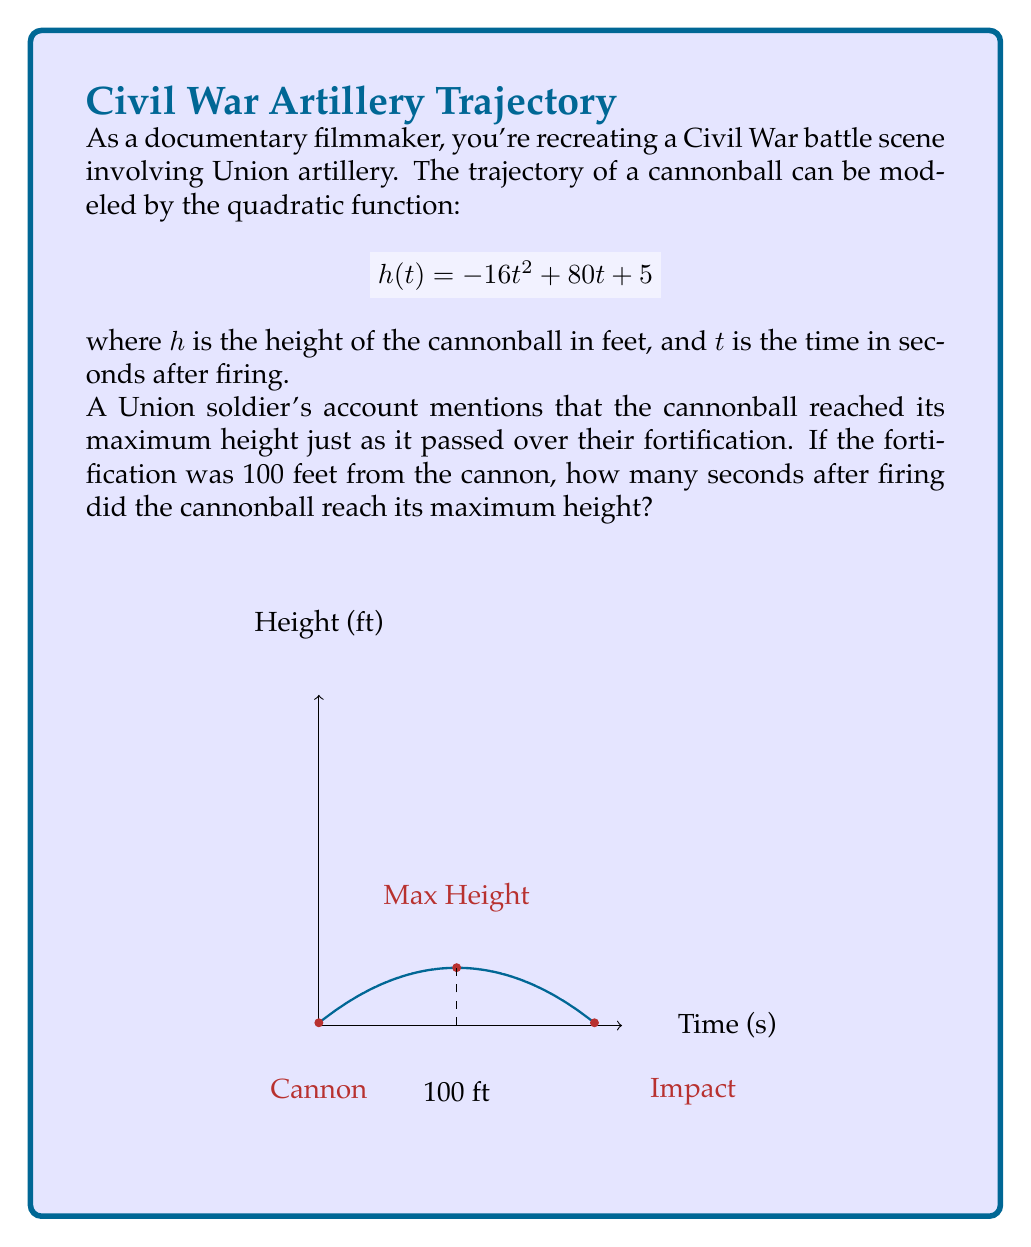Can you answer this question? Let's approach this step-by-step:

1) The quadratic function given is:
   $$h(t) = -16t^2 + 80t + 5$$

2) To find the time when the cannonball reaches its maximum height, we need to find the vertex of this parabola. For a quadratic function in the form $f(x) = ax^2 + bx + c$, the x-coordinate of the vertex is given by $x = -\frac{b}{2a}$.

3) In our case, $a = -16$ and $b = 80$. So:

   $$t = -\frac{80}{2(-16)} = -\frac{80}{-32} = \frac{5}{2} = 2.5$$

4) This means the cannonball reaches its maximum height 2.5 seconds after being fired.

5) To verify, we can calculate the horizontal distance traveled in 2.5 seconds. The horizontal motion of a projectile follows the equation:

   $$d = v_0t$$

   where $d$ is distance, $v_0$ is initial horizontal velocity, and $t$ is time.

6) We can find $v_0$ by taking the derivative of $h(t)$ with respect to $t$ and evaluating at $t=0$:

   $$h'(t) = -32t + 80$$
   $$h'(0) = 80$$

   So the initial velocity is 80 ft/s.

7) The distance traveled in 2.5 seconds is:

   $$d = 80 * 2.5 = 200$$ feet

8) The question states that the fortification was 100 feet from the cannon, which is exactly half of the total horizontal distance traveled when the cannonball reaches its maximum height. This confirms our calculation.
Answer: 2.5 seconds 